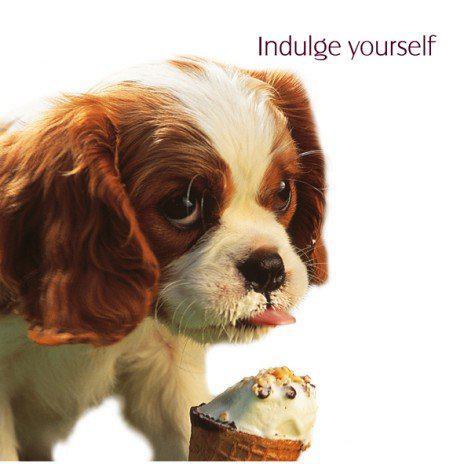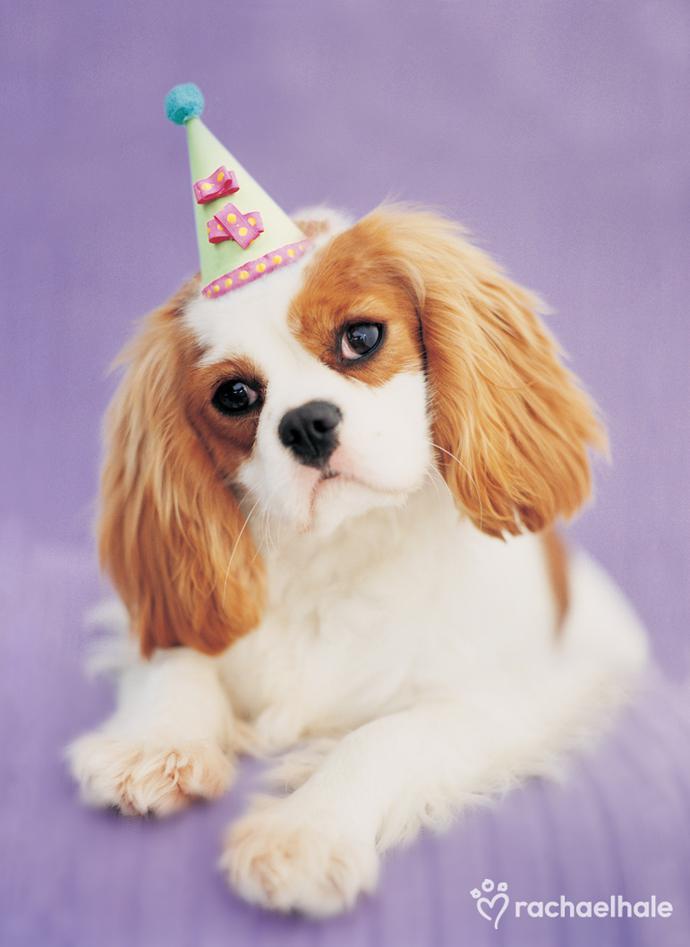The first image is the image on the left, the second image is the image on the right. For the images shown, is this caption "A birthday hat has been placed on at least one puppy's head." true? Answer yes or no. Yes. The first image is the image on the left, the second image is the image on the right. Assess this claim about the two images: "at least one dog in the image pair is wearing a party hat". Correct or not? Answer yes or no. Yes. 